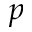<formula> <loc_0><loc_0><loc_500><loc_500>p</formula> 